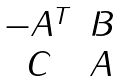<formula> <loc_0><loc_0><loc_500><loc_500>\begin{matrix} - A ^ { T } & B \\ C & A \end{matrix}</formula> 